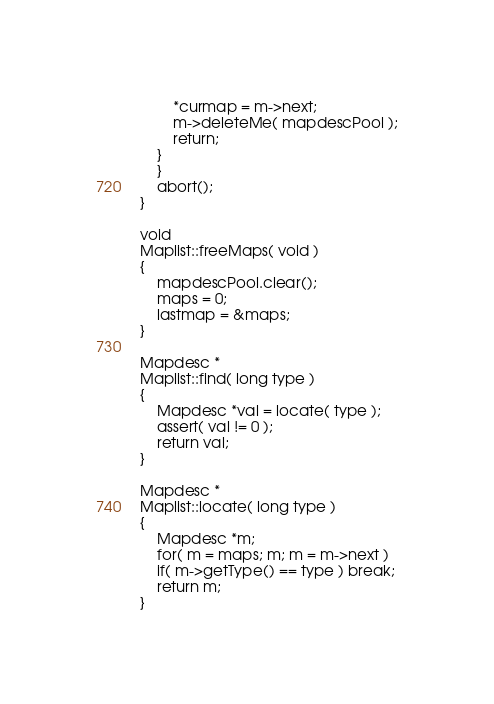Convert code to text. <code><loc_0><loc_0><loc_500><loc_500><_C++_>	    *curmap = m->next;
	    m->deleteMe( mapdescPool );
	    return;
	}
    }
    abort();
}

void
Maplist::freeMaps( void )
{
    mapdescPool.clear();
    maps = 0;
    lastmap = &maps;
}

Mapdesc * 
Maplist::find( long type )
{
    Mapdesc *val = locate( type );
    assert( val != 0 );
    return val;
}

Mapdesc * 
Maplist::locate( long type )
{
    Mapdesc *m;
    for( m = maps; m; m = m->next )
	if( m->getType() == type ) break;
    return m;
}
</code> 